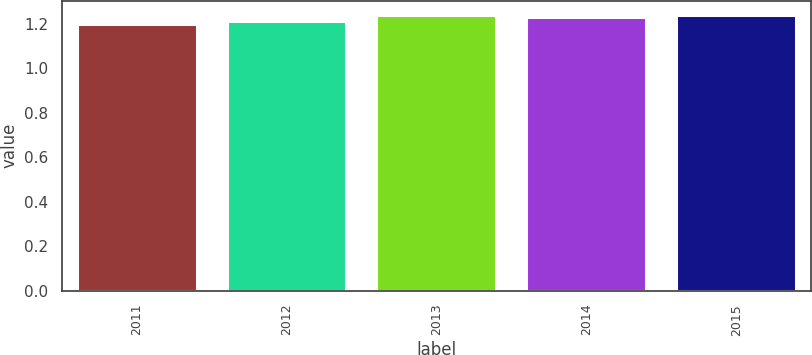Convert chart. <chart><loc_0><loc_0><loc_500><loc_500><bar_chart><fcel>2011<fcel>2012<fcel>2013<fcel>2014<fcel>2015<nl><fcel>1.2<fcel>1.21<fcel>1.24<fcel>1.23<fcel>1.24<nl></chart> 